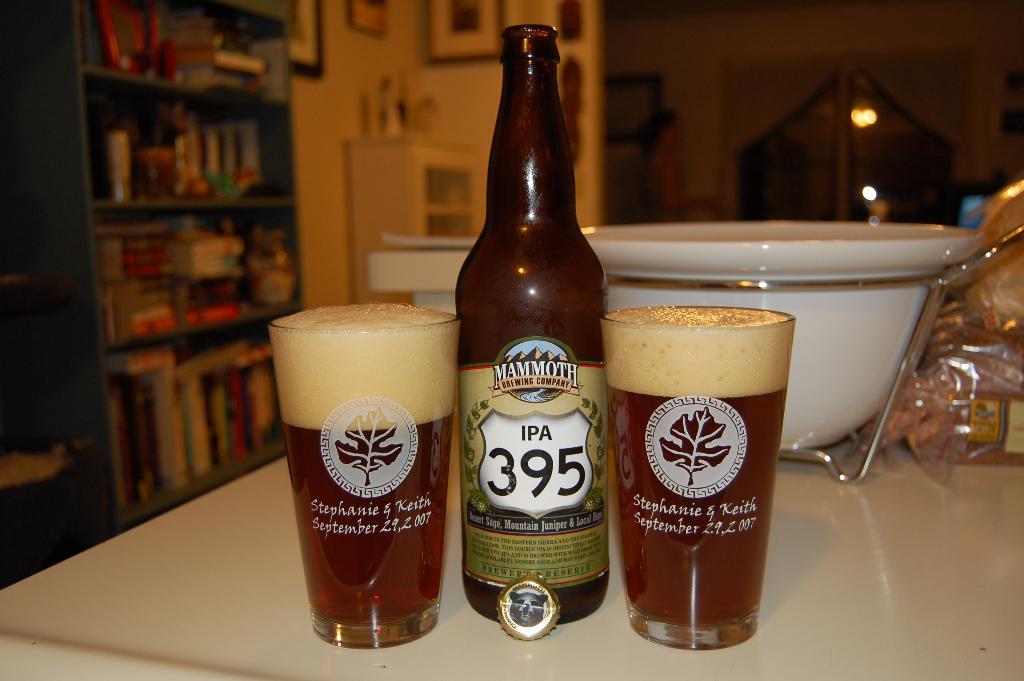What is the brand of beer in the bottle?
Make the answer very short. Mammoth. What is the date on the glasses?
Offer a terse response. September 29, 2007. 